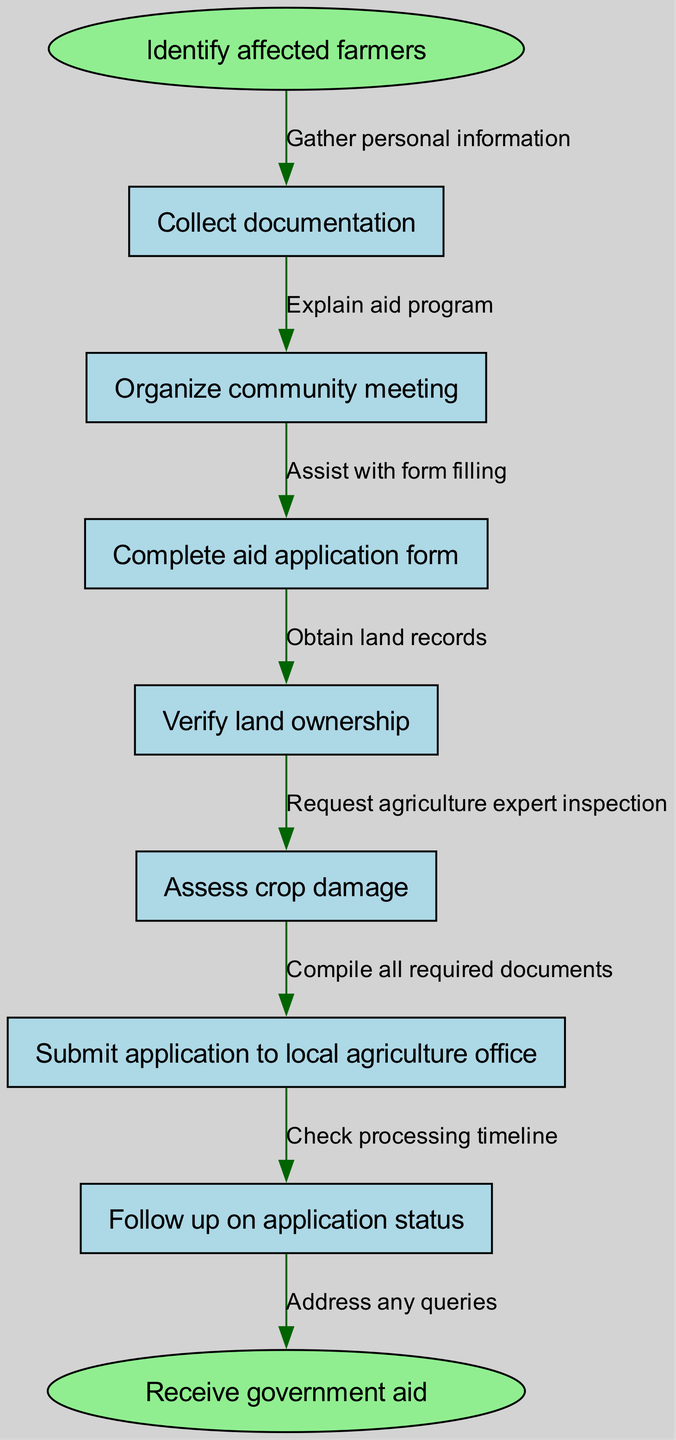What is the starting point of the process? The starting point is labeled as "Identify affected farmers," which is the first node in the flowchart.
Answer: Identify affected farmers How many nodes are present in the diagram? Counting all the nodes, including the start and end nodes, there are a total of 8 nodes in the flowchart.
Answer: 8 What documents must be collected as part of the process? The documentation required is included in the "Collect documentation" node, which indicates that this is a necessary step in the aid application.
Answer: Collect documentation Which node follows "Organize community meeting"? The flowchart indicates that "Complete aid application form" directly follows the "Organize community meeting" node.
Answer: Complete aid application form What is the final step in the process? The final step is labeled "Receive government aid," serving as the conclusion of the flowchart process.
Answer: Receive government aid What edge connects "Assess crop damage" to its preceding node? The edge connecting "Assess crop damage" to "Verify land ownership" is not explicitly labeled at this stage but is implied and significant for moving forward in the flowchart.
Answer: Request agriculture expert inspection How does one verify land ownership according to the diagram? To verify land ownership, the process indicates that obtaining land records is essential, thus linking this step to the verification of ownership.
Answer: Obtain land records What should be done after submitting the application? After submitting the application, the diagram indicates that the next step is to "Follow up on application status," demonstrating the continuation in the application process.
Answer: Follow up on application status What does the edge labeled "Assist with form filling" relate to in the diagram? The edge "Assist with form filling" connects the node "Complete aid application form" to its preceding node, indicating the aid available during form completion.
Answer: Assist with form filling 